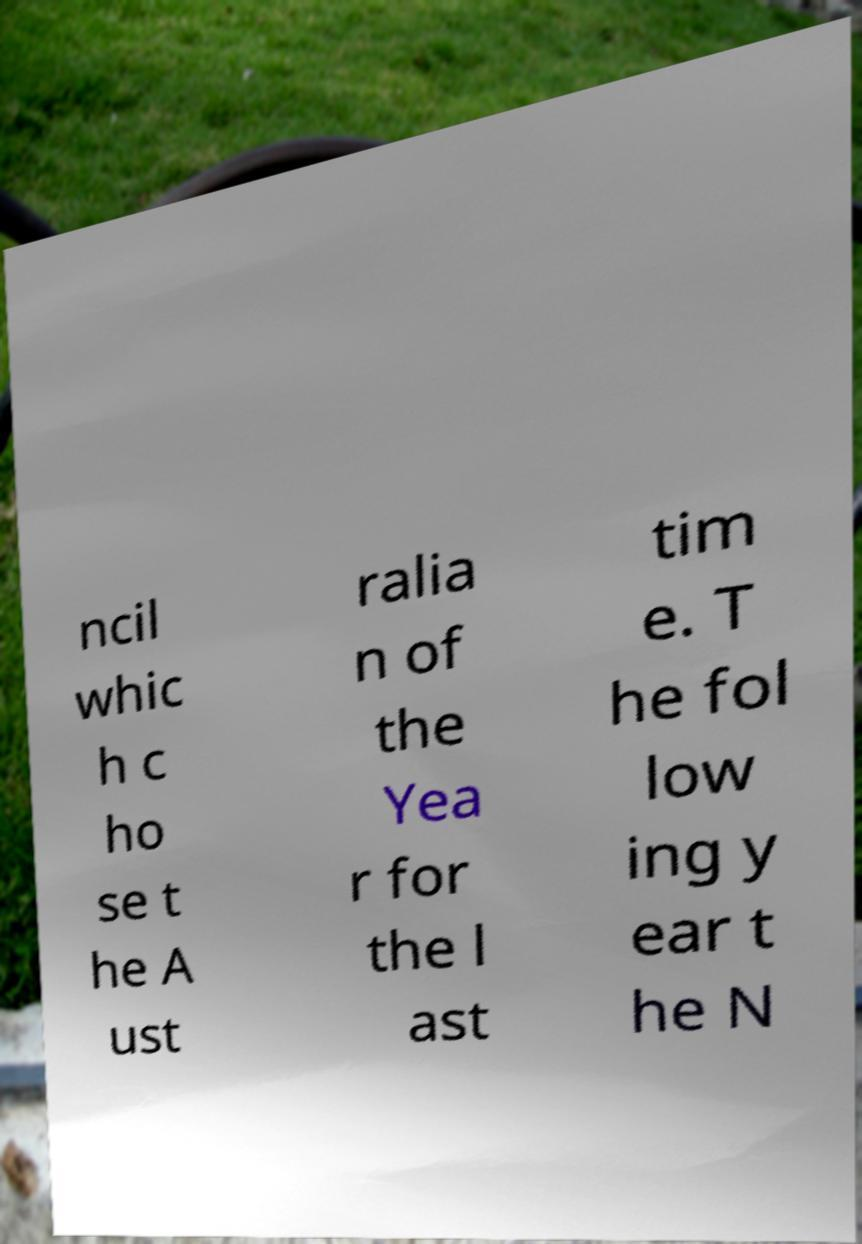Can you read and provide the text displayed in the image?This photo seems to have some interesting text. Can you extract and type it out for me? ncil whic h c ho se t he A ust ralia n of the Yea r for the l ast tim e. T he fol low ing y ear t he N 